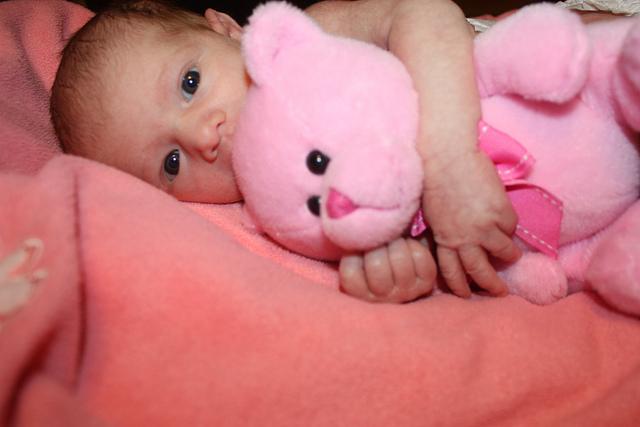What does the baby have in his hands?
Quick response, please. Bear. Is the baby hugging the teddy bear?
Concise answer only. Yes. What is the baby holding?
Keep it brief. Teddy bear. What color is the teddy bear?
Write a very short answer. Pink. How many eyes in the photo?
Concise answer only. 4. 